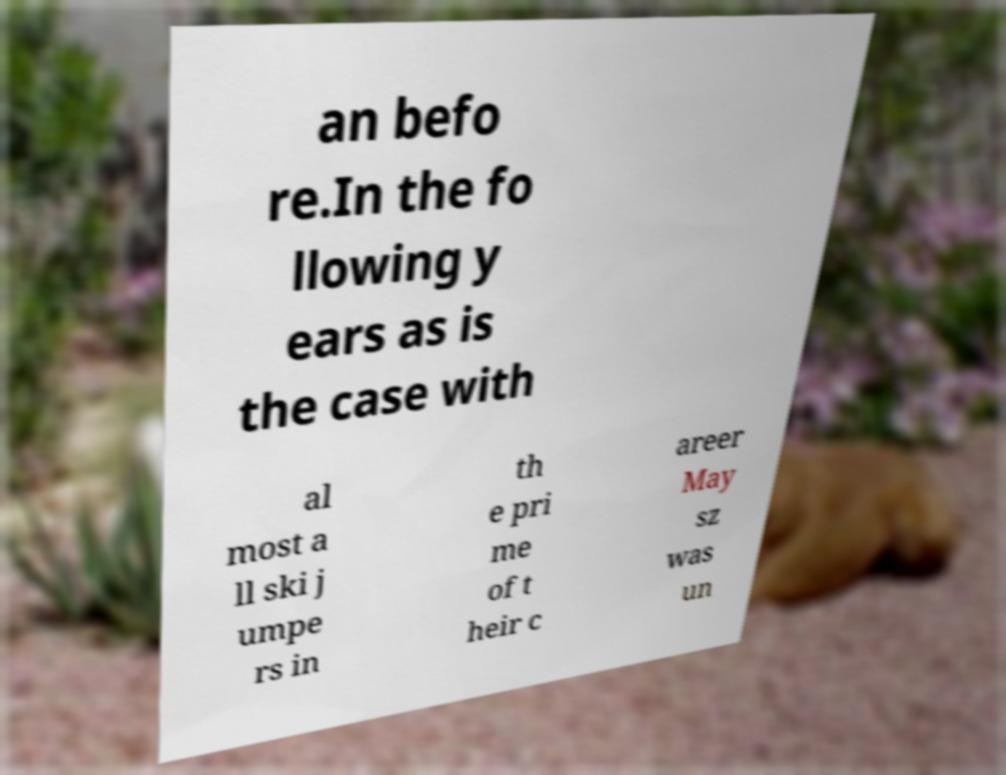Could you assist in decoding the text presented in this image and type it out clearly? an befo re.In the fo llowing y ears as is the case with al most a ll ski j umpe rs in th e pri me of t heir c areer May sz was un 